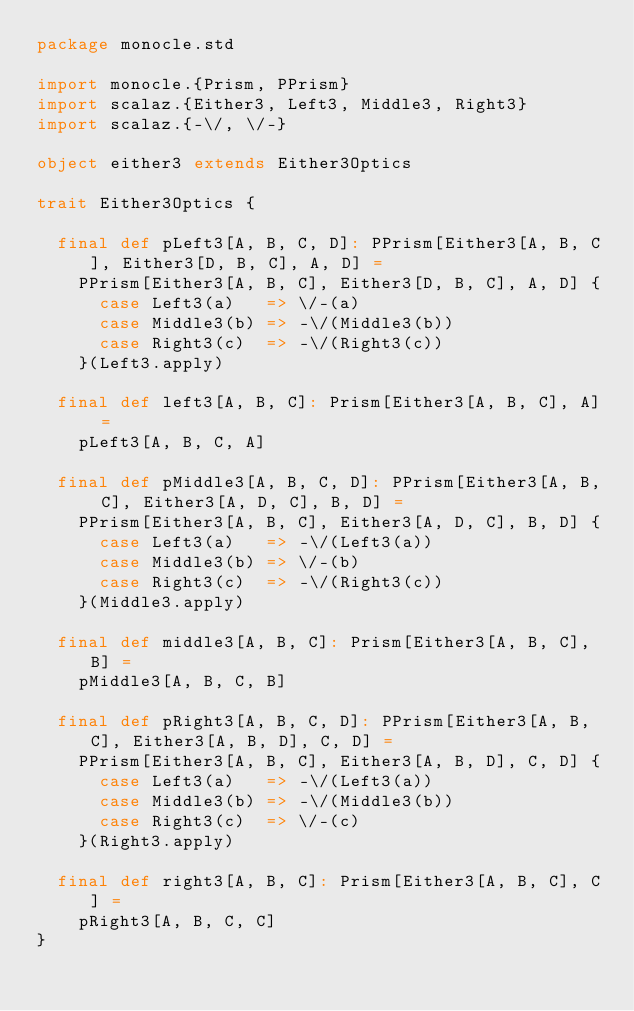Convert code to text. <code><loc_0><loc_0><loc_500><loc_500><_Scala_>package monocle.std

import monocle.{Prism, PPrism}
import scalaz.{Either3, Left3, Middle3, Right3}
import scalaz.{-\/, \/-}

object either3 extends Either3Optics

trait Either3Optics {

  final def pLeft3[A, B, C, D]: PPrism[Either3[A, B, C], Either3[D, B, C], A, D] =
    PPrism[Either3[A, B, C], Either3[D, B, C], A, D] {
      case Left3(a)   => \/-(a)
      case Middle3(b) => -\/(Middle3(b))
      case Right3(c)  => -\/(Right3(c))
    }(Left3.apply)

  final def left3[A, B, C]: Prism[Either3[A, B, C], A] =
    pLeft3[A, B, C, A]

  final def pMiddle3[A, B, C, D]: PPrism[Either3[A, B, C], Either3[A, D, C], B, D] =
    PPrism[Either3[A, B, C], Either3[A, D, C], B, D] {
      case Left3(a)   => -\/(Left3(a))
      case Middle3(b) => \/-(b)
      case Right3(c)  => -\/(Right3(c))
    }(Middle3.apply)

  final def middle3[A, B, C]: Prism[Either3[A, B, C], B] =
    pMiddle3[A, B, C, B]

  final def pRight3[A, B, C, D]: PPrism[Either3[A, B, C], Either3[A, B, D], C, D] =
    PPrism[Either3[A, B, C], Either3[A, B, D], C, D] {
      case Left3(a)   => -\/(Left3(a))
      case Middle3(b) => -\/(Middle3(b))
      case Right3(c)  => \/-(c)
    }(Right3.apply)

  final def right3[A, B, C]: Prism[Either3[A, B, C], C] =
    pRight3[A, B, C, C]
}
</code> 